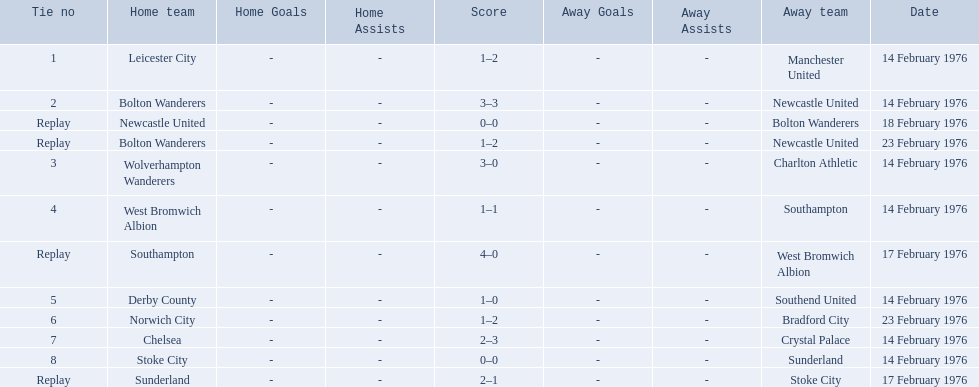What is the game at the top of the table? 1. Who is the home team for this game? Leicester City. 